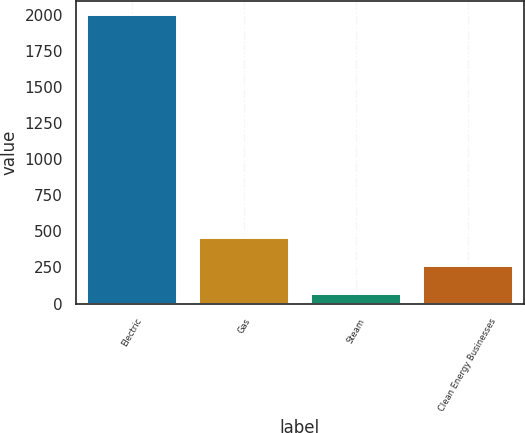Convert chart. <chart><loc_0><loc_0><loc_500><loc_500><bar_chart><fcel>Electric<fcel>Gas<fcel>Steam<fcel>Clean Energy Businesses<nl><fcel>1996<fcel>453.6<fcel>68<fcel>260.8<nl></chart> 